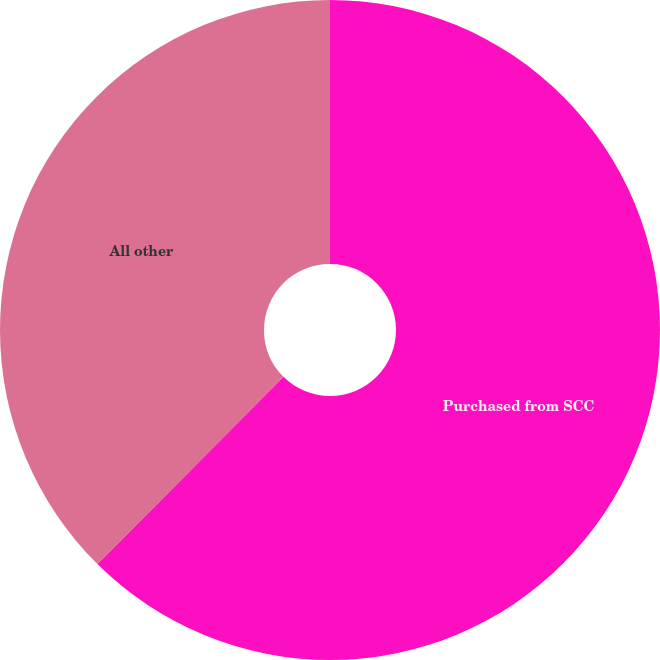Convert chart to OTSL. <chart><loc_0><loc_0><loc_500><loc_500><pie_chart><fcel>Purchased from SCC<fcel>All other<nl><fcel>62.45%<fcel>37.55%<nl></chart> 